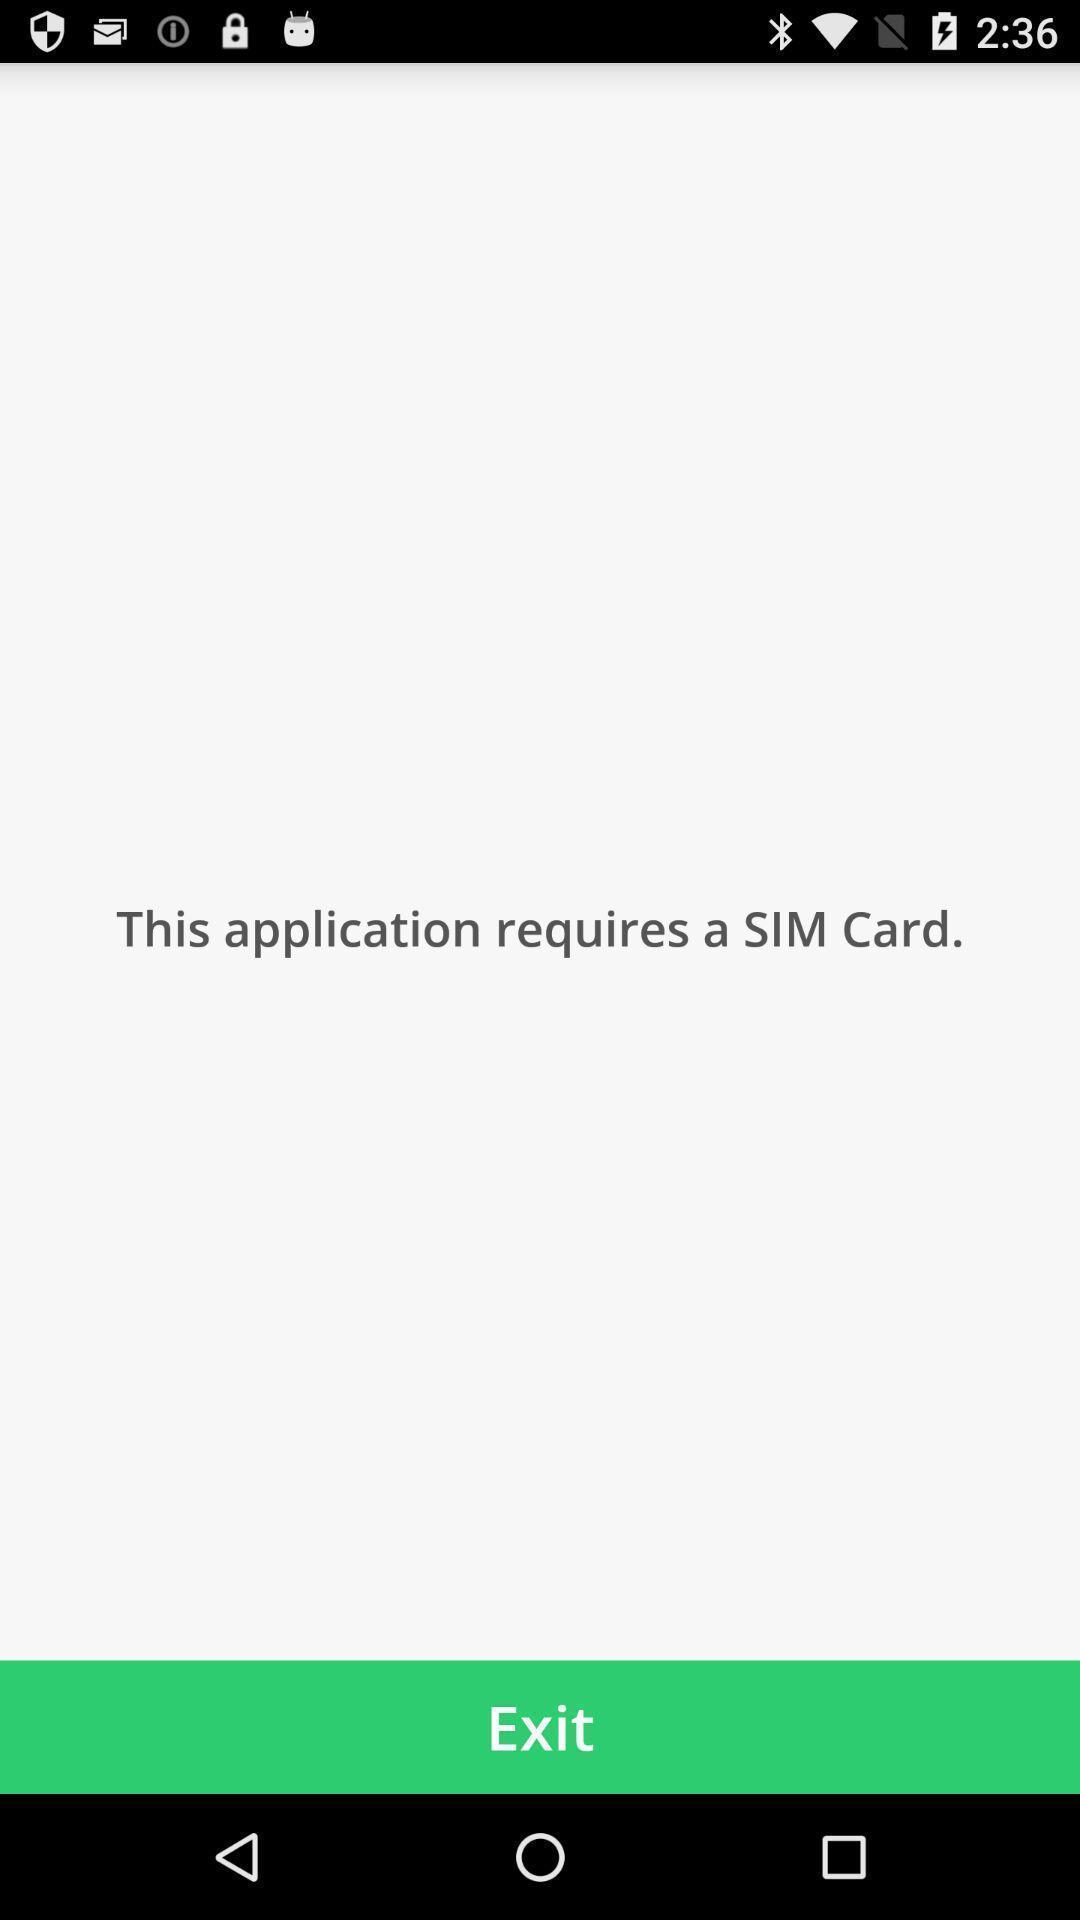Tell me what you see in this picture. Page shows the application requires a sim card. 